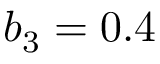Convert formula to latex. <formula><loc_0><loc_0><loc_500><loc_500>b _ { 3 } = 0 . 4</formula> 